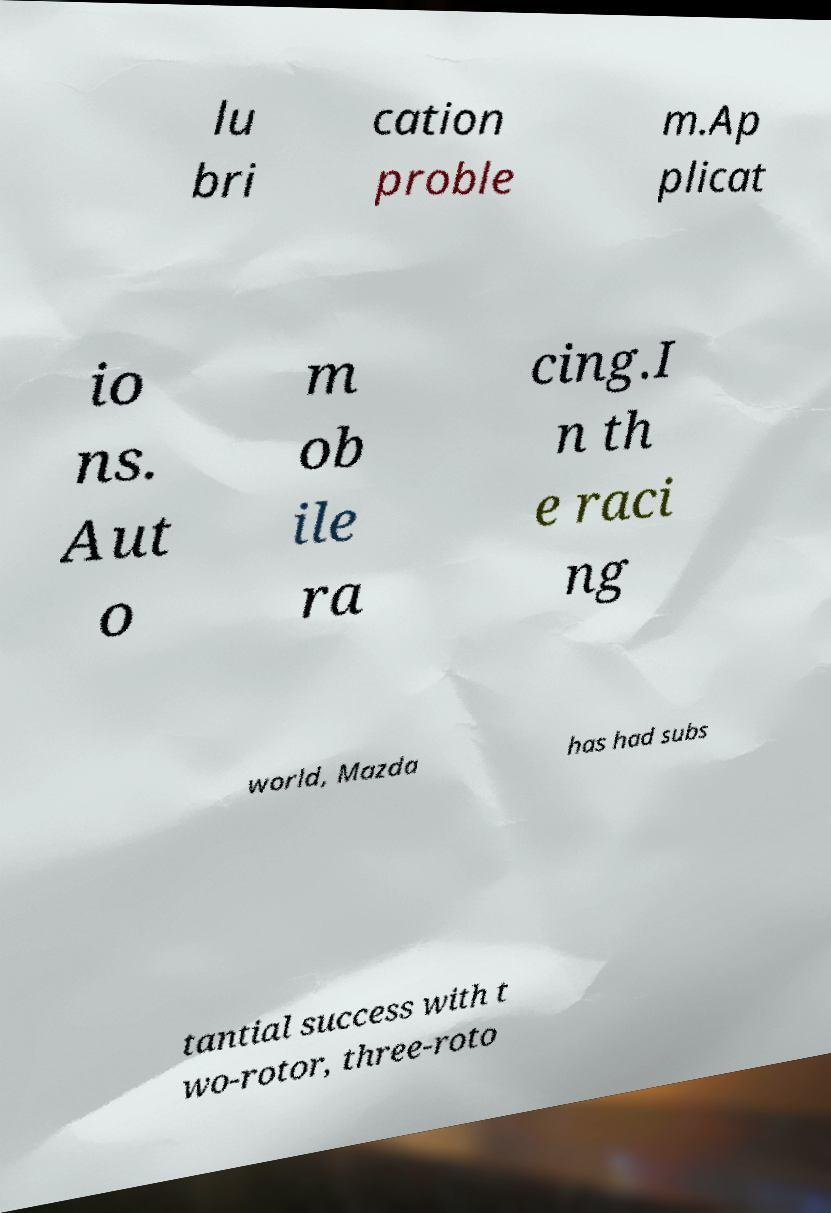What messages or text are displayed in this image? I need them in a readable, typed format. lu bri cation proble m.Ap plicat io ns. Aut o m ob ile ra cing.I n th e raci ng world, Mazda has had subs tantial success with t wo-rotor, three-roto 